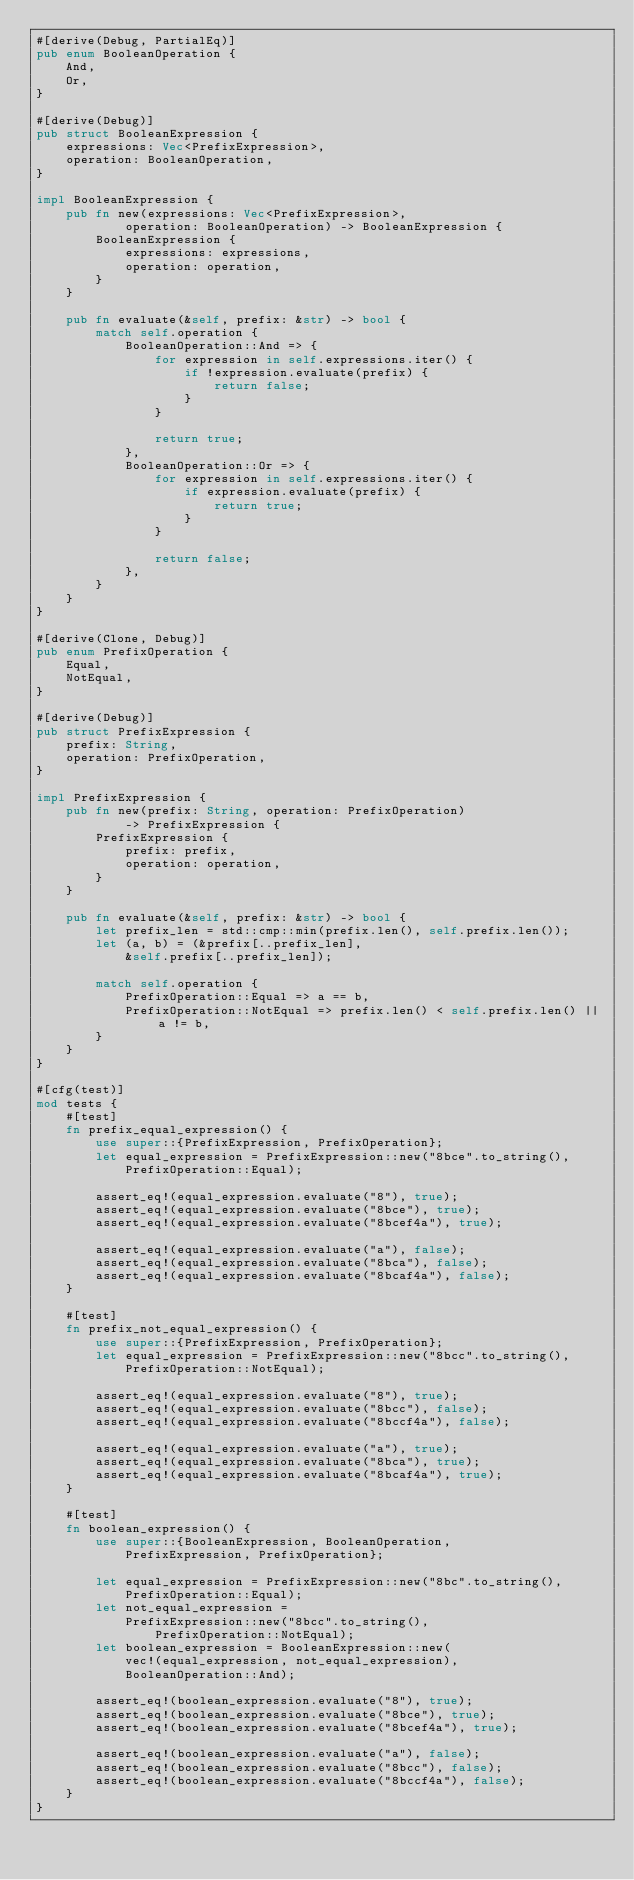<code> <loc_0><loc_0><loc_500><loc_500><_Rust_>#[derive(Debug, PartialEq)]
pub enum BooleanOperation {
    And,
    Or,
}

#[derive(Debug)]
pub struct BooleanExpression {
    expressions: Vec<PrefixExpression>,
    operation: BooleanOperation,
}

impl BooleanExpression {
    pub fn new(expressions: Vec<PrefixExpression>,
            operation: BooleanOperation) -> BooleanExpression {
        BooleanExpression {
            expressions: expressions,
            operation: operation,
        }
    }

    pub fn evaluate(&self, prefix: &str) -> bool {
        match self.operation {
            BooleanOperation::And => {
                for expression in self.expressions.iter() {
                    if !expression.evaluate(prefix) {
                        return false;
                    }
                }

                return true;
            },
            BooleanOperation::Or => {
                for expression in self.expressions.iter() {
                    if expression.evaluate(prefix) {
                        return true;
                    }
                }

                return false;
            },
        }
    }
}

#[derive(Clone, Debug)]
pub enum PrefixOperation {
    Equal,
    NotEqual,
}

#[derive(Debug)]
pub struct PrefixExpression {
    prefix: String,
    operation: PrefixOperation,
}

impl PrefixExpression {
    pub fn new(prefix: String, operation: PrefixOperation)
            -> PrefixExpression {
        PrefixExpression {
            prefix: prefix,
            operation: operation,
        }
    }

    pub fn evaluate(&self, prefix: &str) -> bool {
        let prefix_len = std::cmp::min(prefix.len(), self.prefix.len());
        let (a, b) = (&prefix[..prefix_len],
            &self.prefix[..prefix_len]);

        match self.operation {
            PrefixOperation::Equal => a == b,
            PrefixOperation::NotEqual => prefix.len() < self.prefix.len() || a != b,
        }
    }
}

#[cfg(test)]
mod tests {
    #[test]
    fn prefix_equal_expression() {
        use super::{PrefixExpression, PrefixOperation};
        let equal_expression = PrefixExpression::new("8bce".to_string(),
            PrefixOperation::Equal);

        assert_eq!(equal_expression.evaluate("8"), true);
        assert_eq!(equal_expression.evaluate("8bce"), true);
        assert_eq!(equal_expression.evaluate("8bcef4a"), true);

        assert_eq!(equal_expression.evaluate("a"), false);
        assert_eq!(equal_expression.evaluate("8bca"), false);
        assert_eq!(equal_expression.evaluate("8bcaf4a"), false);
    }

    #[test]
    fn prefix_not_equal_expression() {
        use super::{PrefixExpression, PrefixOperation};
        let equal_expression = PrefixExpression::new("8bcc".to_string(),
            PrefixOperation::NotEqual);

        assert_eq!(equal_expression.evaluate("8"), true);
        assert_eq!(equal_expression.evaluate("8bcc"), false);
        assert_eq!(equal_expression.evaluate("8bccf4a"), false);

        assert_eq!(equal_expression.evaluate("a"), true);
        assert_eq!(equal_expression.evaluate("8bca"), true);
        assert_eq!(equal_expression.evaluate("8bcaf4a"), true);
    }

    #[test]
    fn boolean_expression() {
        use super::{BooleanExpression, BooleanOperation,
            PrefixExpression, PrefixOperation};

        let equal_expression = PrefixExpression::new("8bc".to_string(),
            PrefixOperation::Equal);
        let not_equal_expression =
            PrefixExpression::new("8bcc".to_string(),
                PrefixOperation::NotEqual);
        let boolean_expression = BooleanExpression::new(
            vec!(equal_expression, not_equal_expression),
            BooleanOperation::And);

        assert_eq!(boolean_expression.evaluate("8"), true);
        assert_eq!(boolean_expression.evaluate("8bce"), true);
        assert_eq!(boolean_expression.evaluate("8bcef4a"), true);

        assert_eq!(boolean_expression.evaluate("a"), false);
        assert_eq!(boolean_expression.evaluate("8bcc"), false);
        assert_eq!(boolean_expression.evaluate("8bccf4a"), false);
    }
}
</code> 